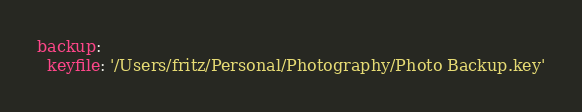<code> <loc_0><loc_0><loc_500><loc_500><_YAML_>backup:
  keyfile: '/Users/fritz/Personal/Photography/Photo Backup.key'</code> 